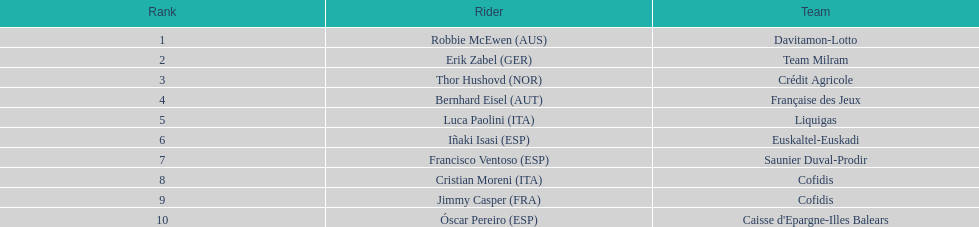What was the point gap between erik zabel and francisco ventoso? 71. 